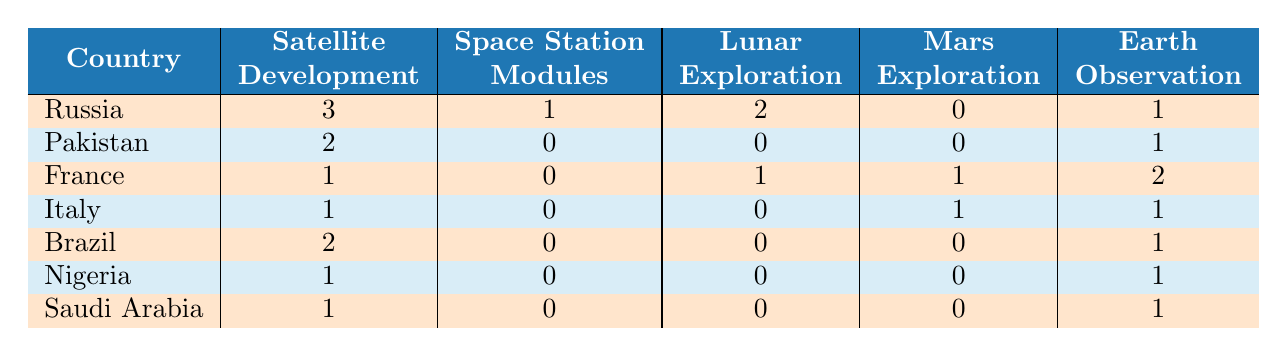What is the total number of satellite development collaborations with Russia? According to the table, Russia has 3 collaborations in satellite development.
Answer: 3 How many countries collaborated with China on Mars exploration? The table shows that France (1), Italy (1), and Russia (0, does not contribute), thus there are 2 countries that collaborated on Mars exploration.
Answer: 2 Did any country collaborate with China on space station modules? The table indicates that only Russia has collaborations on space station modules (1), while others have 0.
Answer: Yes Which country has the highest number of collaborations in Earth observation? By examining the table, France has the highest number of collaborations in Earth observation with 2, while others have either 1 or 0.
Answer: France What is the sum of lunar exploration collaborations between Russia and France? Russia has 2 collaborations in lunar exploration and France has 1, so the sum is 2 + 1 = 3.
Answer: 3 How many countries have zero collaborations in Mars exploration? The table shows that Russia, Pakistan, Brazil, Nigeria, and Saudi Arabia all contributed 0 collaborations in Mars exploration, so there are 5 countries with zero.
Answer: 5 Which two types of projects had the maximum collaborations with Pakistan? Looking at Pakistan's collaborations, the maximum is in satellite development (2) and Earth observation (1). The total maximum project types are 2 and 1.
Answer: 2 and 1 What is the average number of lunar exploration collaborations across all listed countries? Adding up the lunar exploration collaborations: Russia (2) + France (1) + others (0) = 3. There are 7 countries, thus the average is 3/7 ≈ 0.43.
Answer: Approximately 0.43 How does the total number of Earth observation collaborations compare between Brazil and Nigeria? Brazil has 1 and Nigeria also has 1 collaboration in Earth observation, hence they are equal.
Answer: Equal What is the difference in satellite development collaborations between Russia and Pakistan? Russia has 3 collaborations in satellite development, while Pakistan has 2. The difference is 3 - 2 = 1.
Answer: 1 